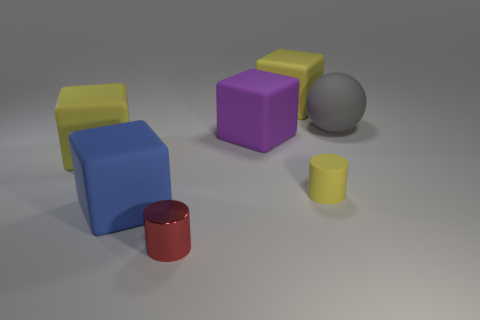Add 1 large cyan balls. How many objects exist? 8 Subtract all blue cubes. How many cubes are left? 3 Subtract all purple rubber blocks. How many blocks are left? 3 Subtract all cubes. How many objects are left? 3 Subtract all red blocks. Subtract all brown spheres. How many blocks are left? 4 Subtract all blue things. Subtract all big yellow matte cubes. How many objects are left? 4 Add 1 small yellow rubber cylinders. How many small yellow rubber cylinders are left? 2 Add 4 gray spheres. How many gray spheres exist? 5 Subtract 1 yellow blocks. How many objects are left? 6 